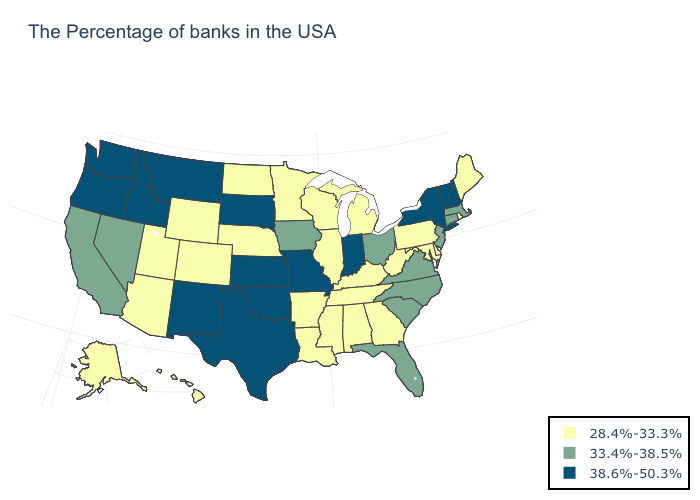What is the lowest value in the USA?
Write a very short answer. 28.4%-33.3%. Does Indiana have the highest value in the USA?
Give a very brief answer. Yes. Does the map have missing data?
Answer briefly. No. Does the first symbol in the legend represent the smallest category?
Keep it brief. Yes. Does Minnesota have a lower value than Alaska?
Write a very short answer. No. What is the value of Alabama?
Quick response, please. 28.4%-33.3%. What is the value of Hawaii?
Short answer required. 28.4%-33.3%. Is the legend a continuous bar?
Concise answer only. No. Among the states that border Michigan , does Indiana have the highest value?
Give a very brief answer. Yes. Name the states that have a value in the range 38.6%-50.3%?
Concise answer only. New Hampshire, Vermont, New York, Indiana, Missouri, Kansas, Oklahoma, Texas, South Dakota, New Mexico, Montana, Idaho, Washington, Oregon. What is the value of Connecticut?
Keep it brief. 33.4%-38.5%. What is the highest value in states that border Oklahoma?
Be succinct. 38.6%-50.3%. Name the states that have a value in the range 33.4%-38.5%?
Keep it brief. Massachusetts, Connecticut, New Jersey, Virginia, North Carolina, South Carolina, Ohio, Florida, Iowa, Nevada, California. Among the states that border New Mexico , which have the highest value?
Be succinct. Oklahoma, Texas. What is the value of Idaho?
Give a very brief answer. 38.6%-50.3%. 